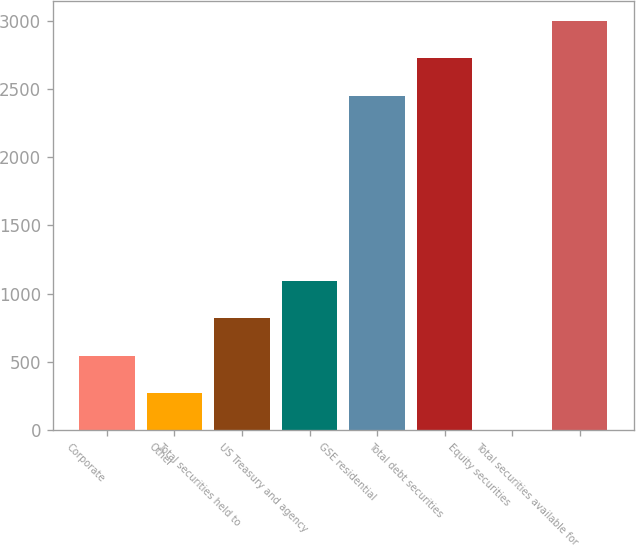<chart> <loc_0><loc_0><loc_500><loc_500><bar_chart><fcel>Corporate<fcel>Other<fcel>Total securities held to<fcel>US Treasury and agency<fcel>GSE residential<fcel>Total debt securities<fcel>Equity securities<fcel>Total securities available for<nl><fcel>545.26<fcel>272.73<fcel>817.79<fcel>1090.32<fcel>2447.8<fcel>2725.3<fcel>0.2<fcel>2997.83<nl></chart> 